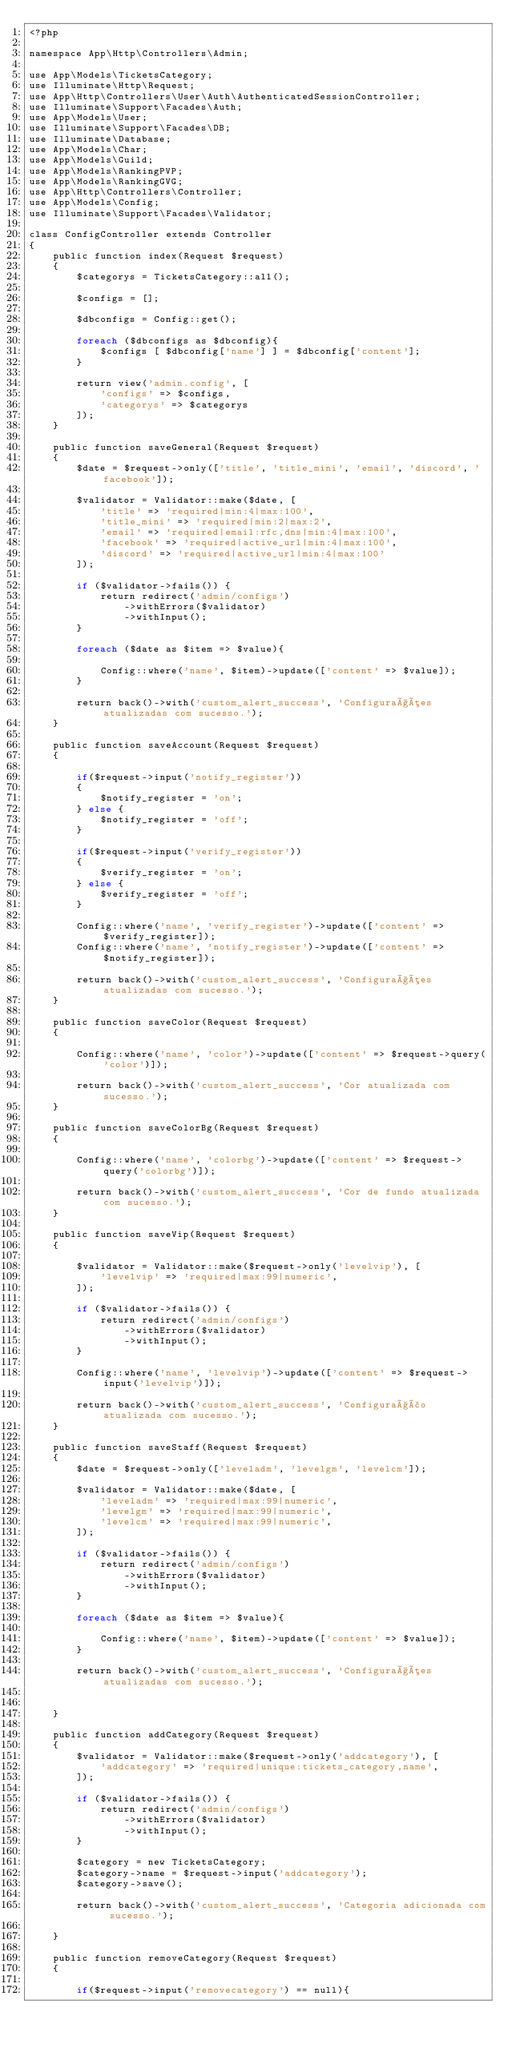<code> <loc_0><loc_0><loc_500><loc_500><_PHP_><?php

namespace App\Http\Controllers\Admin;

use App\Models\TicketsCategory;
use Illuminate\Http\Request;
use App\Http\Controllers\User\Auth\AuthenticatedSessionController;
use Illuminate\Support\Facades\Auth;
use App\Models\User;
use Illuminate\Support\Facades\DB;
use Illuminate\Database;
use App\Models\Char;
use App\Models\Guild;
use App\Models\RankingPVP;
use App\Models\RankingGVG;
use App\Http\Controllers\Controller;
use App\Models\Config;
use Illuminate\Support\Facades\Validator;

class ConfigController extends Controller
{
    public function index(Request $request)
    {
        $categorys = TicketsCategory::all();

        $configs = [];

        $dbconfigs = Config::get();

        foreach ($dbconfigs as $dbconfig){
            $configs [ $dbconfig['name'] ] = $dbconfig['content'];
        }

        return view('admin.config', [
            'configs' => $configs,
            'categorys' => $categorys
        ]);
    }

    public function saveGeneral(Request $request)
    {
        $date = $request->only(['title', 'title_mini', 'email', 'discord', 'facebook']);

        $validator = Validator::make($date, [
            'title' => 'required|min:4|max:100',
            'title_mini' => 'required|min:2|max:2',
            'email' => 'required|email:rfc,dns|min:4|max:100',
            'facebook' => 'required|active_url|min:4|max:100',
            'discord' => 'required|active_url|min:4|max:100'
        ]);

        if ($validator->fails()) {
            return redirect('admin/configs')
                ->withErrors($validator)
                ->withInput();
        }

        foreach ($date as $item => $value){

            Config::where('name', $item)->update(['content' => $value]);
        }

        return back()->with('custom_alert_success', 'Configurações atualizadas com sucesso.');
    }

    public function saveAccount(Request $request)
    {

        if($request->input('notify_register'))
        {
            $notify_register = 'on';
        } else {
            $notify_register = 'off';
        }

        if($request->input('verify_register'))
        {
            $verify_register = 'on';
        } else {
            $verify_register = 'off';
        }

        Config::where('name', 'verify_register')->update(['content' => $verify_register]);
        Config::where('name', 'notify_register')->update(['content' => $notify_register]);

        return back()->with('custom_alert_success', 'Configurações atualizadas com sucesso.');
    }

    public function saveColor(Request $request)
    {

        Config::where('name', 'color')->update(['content' => $request->query('color')]);

        return back()->with('custom_alert_success', 'Cor atualizada com sucesso.');
    }

    public function saveColorBg(Request $request)
    {

        Config::where('name', 'colorbg')->update(['content' => $request->query('colorbg')]);

        return back()->with('custom_alert_success', 'Cor de fundo atualizada com sucesso.');
    }

    public function saveVip(Request $request)
    {

        $validator = Validator::make($request->only('levelvip'), [
            'levelvip' => 'required|max:99|numeric',
        ]);

        if ($validator->fails()) {
            return redirect('admin/configs')
                ->withErrors($validator)
                ->withInput();
        }

        Config::where('name', 'levelvip')->update(['content' => $request->input('levelvip')]);

        return back()->with('custom_alert_success', 'Configuração atualizada com sucesso.');
    }

    public function saveStaff(Request $request)
    {
        $date = $request->only(['leveladm', 'levelgm', 'levelcm']);

        $validator = Validator::make($date, [
            'leveladm' => 'required|max:99|numeric',
            'levelgm' => 'required|max:99|numeric',
            'levelcm' => 'required|max:99|numeric',
        ]);

        if ($validator->fails()) {
            return redirect('admin/configs')
                ->withErrors($validator)
                ->withInput();
        }

        foreach ($date as $item => $value){

            Config::where('name', $item)->update(['content' => $value]);
        }

        return back()->with('custom_alert_success', 'Configurações atualizadas com sucesso.');


    }

    public function addCategory(Request $request)
    {
        $validator = Validator::make($request->only('addcategory'), [
            'addcategory' => 'required|unique:tickets_category,name',
        ]);

        if ($validator->fails()) {
            return redirect('admin/configs')
                ->withErrors($validator)
                ->withInput();
        }

        $category = new TicketsCategory;
        $category->name = $request->input('addcategory');
        $category->save();

        return back()->with('custom_alert_success', 'Categoria adicionada com sucesso.');

    }

    public function removeCategory(Request $request)
    {

        if($request->input('removecategory') == null){
</code> 